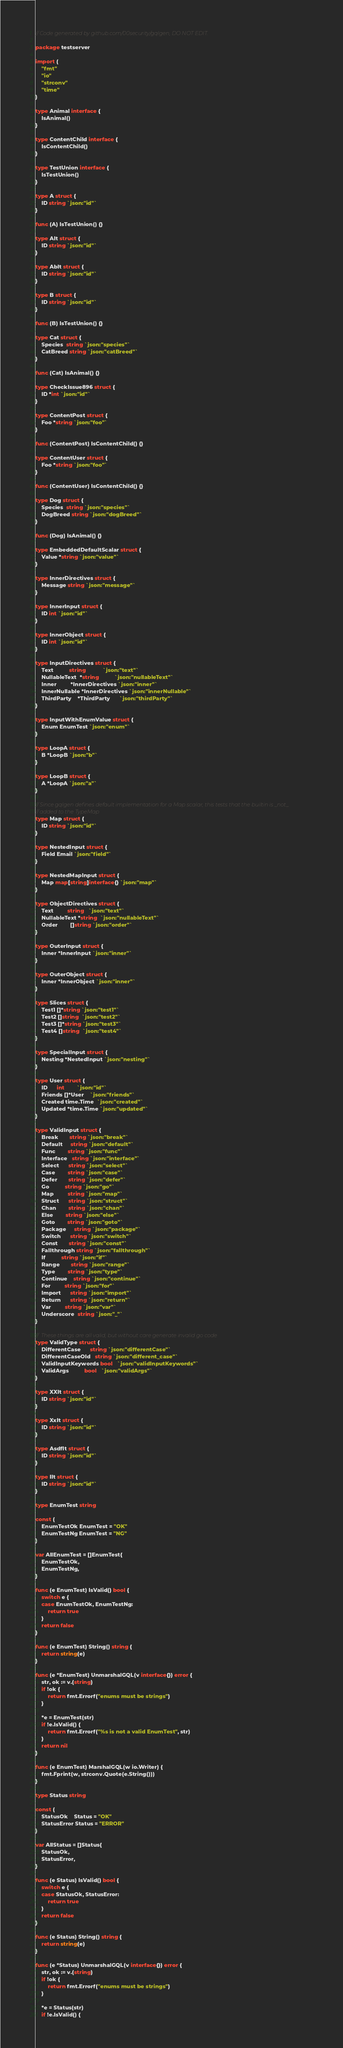Convert code to text. <code><loc_0><loc_0><loc_500><loc_500><_Go_>// Code generated by github.com/00security/gqlgen, DO NOT EDIT.

package testserver

import (
	"fmt"
	"io"
	"strconv"
	"time"
)

type Animal interface {
	IsAnimal()
}

type ContentChild interface {
	IsContentChild()
}

type TestUnion interface {
	IsTestUnion()
}

type A struct {
	ID string `json:"id"`
}

func (A) IsTestUnion() {}

type AIt struct {
	ID string `json:"id"`
}

type AbIt struct {
	ID string `json:"id"`
}

type B struct {
	ID string `json:"id"`
}

func (B) IsTestUnion() {}

type Cat struct {
	Species  string `json:"species"`
	CatBreed string `json:"catBreed"`
}

func (Cat) IsAnimal() {}

type CheckIssue896 struct {
	ID *int `json:"id"`
}

type ContentPost struct {
	Foo *string `json:"foo"`
}

func (ContentPost) IsContentChild() {}

type ContentUser struct {
	Foo *string `json:"foo"`
}

func (ContentUser) IsContentChild() {}

type Dog struct {
	Species  string `json:"species"`
	DogBreed string `json:"dogBreed"`
}

func (Dog) IsAnimal() {}

type EmbeddedDefaultScalar struct {
	Value *string `json:"value"`
}

type InnerDirectives struct {
	Message string `json:"message"`
}

type InnerInput struct {
	ID int `json:"id"`
}

type InnerObject struct {
	ID int `json:"id"`
}

type InputDirectives struct {
	Text          string           `json:"text"`
	NullableText  *string          `json:"nullableText"`
	Inner         *InnerDirectives `json:"inner"`
	InnerNullable *InnerDirectives `json:"innerNullable"`
	ThirdParty    *ThirdParty      `json:"thirdParty"`
}

type InputWithEnumValue struct {
	Enum EnumTest `json:"enum"`
}

type LoopA struct {
	B *LoopB `json:"b"`
}

type LoopB struct {
	A *LoopA `json:"a"`
}

// Since gqlgen defines default implementation for a Map scalar, this tests that the builtin is _not_
// added to the TypeMap
type Map struct {
	ID string `json:"id"`
}

type NestedInput struct {
	Field Email `json:"field"`
}

type NestedMapInput struct {
	Map map[string]interface{} `json:"map"`
}

type ObjectDirectives struct {
	Text         string   `json:"text"`
	NullableText *string  `json:"nullableText"`
	Order        []string `json:"order"`
}

type OuterInput struct {
	Inner *InnerInput `json:"inner"`
}

type OuterObject struct {
	Inner *InnerObject `json:"inner"`
}

type Slices struct {
	Test1 []*string `json:"test1"`
	Test2 []string  `json:"test2"`
	Test3 []*string `json:"test3"`
	Test4 []string  `json:"test4"`
}

type SpecialInput struct {
	Nesting *NestedInput `json:"nesting"`
}

type User struct {
	ID      int        `json:"id"`
	Friends []*User    `json:"friends"`
	Created time.Time  `json:"created"`
	Updated *time.Time `json:"updated"`
}

type ValidInput struct {
	Break       string `json:"break"`
	Default     string `json:"default"`
	Func        string `json:"func"`
	Interface   string `json:"interface"`
	Select      string `json:"select"`
	Case        string `json:"case"`
	Defer       string `json:"defer"`
	Go          string `json:"go"`
	Map         string `json:"map"`
	Struct      string `json:"struct"`
	Chan        string `json:"chan"`
	Else        string `json:"else"`
	Goto        string `json:"goto"`
	Package     string `json:"package"`
	Switch      string `json:"switch"`
	Const       string `json:"const"`
	Fallthrough string `json:"fallthrough"`
	If          string `json:"if"`
	Range       string `json:"range"`
	Type        string `json:"type"`
	Continue    string `json:"continue"`
	For         string `json:"for"`
	Import      string `json:"import"`
	Return      string `json:"return"`
	Var         string `json:"var"`
	Underscore  string `json:"_"`
}

//  These things are all valid, but without care generate invalid go code
type ValidType struct {
	DifferentCase      string `json:"differentCase"`
	DifferentCaseOld   string `json:"different_case"`
	ValidInputKeywords bool   `json:"validInputKeywords"`
	ValidArgs          bool   `json:"validArgs"`
}

type XXIt struct {
	ID string `json:"id"`
}

type XxIt struct {
	ID string `json:"id"`
}

type AsdfIt struct {
	ID string `json:"id"`
}

type IIt struct {
	ID string `json:"id"`
}

type EnumTest string

const (
	EnumTestOk EnumTest = "OK"
	EnumTestNg EnumTest = "NG"
)

var AllEnumTest = []EnumTest{
	EnumTestOk,
	EnumTestNg,
}

func (e EnumTest) IsValid() bool {
	switch e {
	case EnumTestOk, EnumTestNg:
		return true
	}
	return false
}

func (e EnumTest) String() string {
	return string(e)
}

func (e *EnumTest) UnmarshalGQL(v interface{}) error {
	str, ok := v.(string)
	if !ok {
		return fmt.Errorf("enums must be strings")
	}

	*e = EnumTest(str)
	if !e.IsValid() {
		return fmt.Errorf("%s is not a valid EnumTest", str)
	}
	return nil
}

func (e EnumTest) MarshalGQL(w io.Writer) {
	fmt.Fprint(w, strconv.Quote(e.String()))
}

type Status string

const (
	StatusOk    Status = "OK"
	StatusError Status = "ERROR"
)

var AllStatus = []Status{
	StatusOk,
	StatusError,
}

func (e Status) IsValid() bool {
	switch e {
	case StatusOk, StatusError:
		return true
	}
	return false
}

func (e Status) String() string {
	return string(e)
}

func (e *Status) UnmarshalGQL(v interface{}) error {
	str, ok := v.(string)
	if !ok {
		return fmt.Errorf("enums must be strings")
	}

	*e = Status(str)
	if !e.IsValid() {</code> 